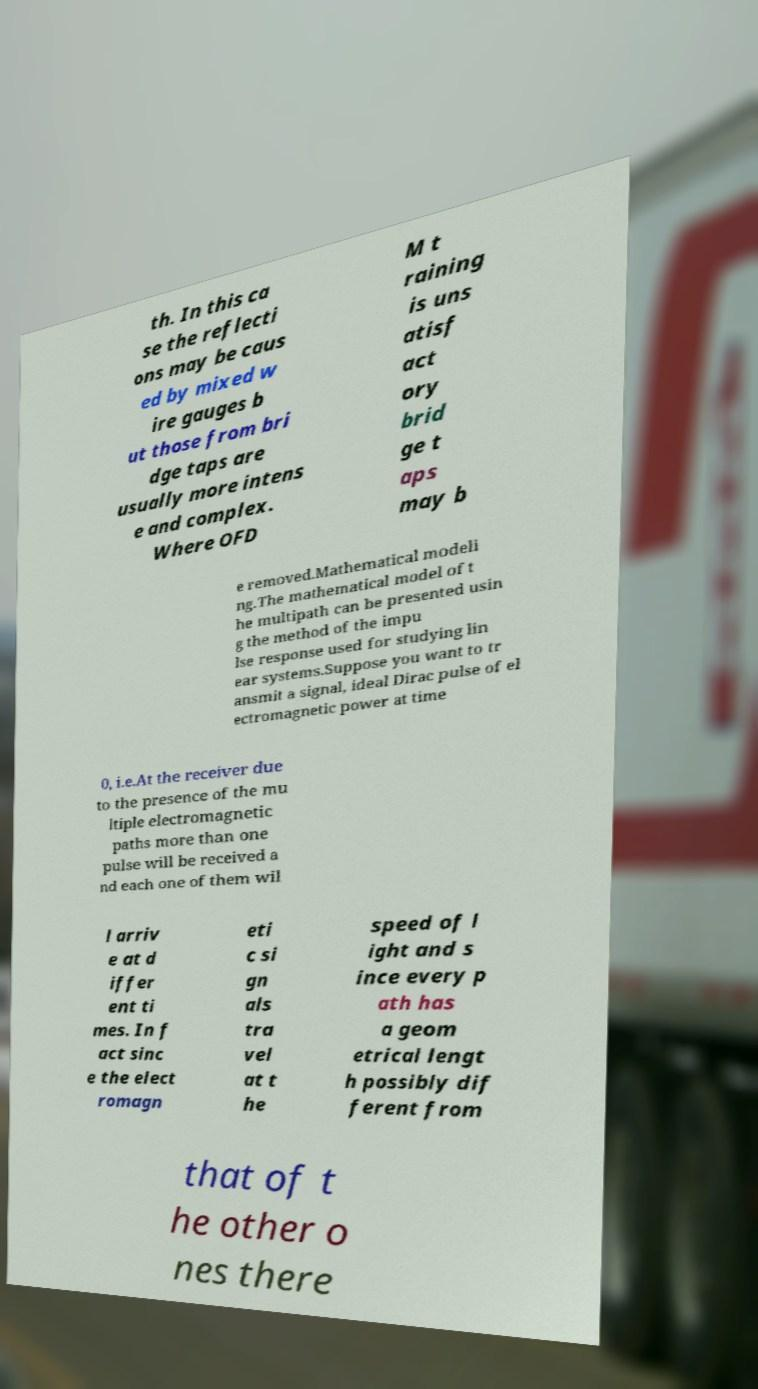Please read and relay the text visible in this image. What does it say? th. In this ca se the reflecti ons may be caus ed by mixed w ire gauges b ut those from bri dge taps are usually more intens e and complex. Where OFD M t raining is uns atisf act ory brid ge t aps may b e removed.Mathematical modeli ng.The mathematical model of t he multipath can be presented usin g the method of the impu lse response used for studying lin ear systems.Suppose you want to tr ansmit a signal, ideal Dirac pulse of el ectromagnetic power at time 0, i.e.At the receiver due to the presence of the mu ltiple electromagnetic paths more than one pulse will be received a nd each one of them wil l arriv e at d iffer ent ti mes. In f act sinc e the elect romagn eti c si gn als tra vel at t he speed of l ight and s ince every p ath has a geom etrical lengt h possibly dif ferent from that of t he other o nes there 